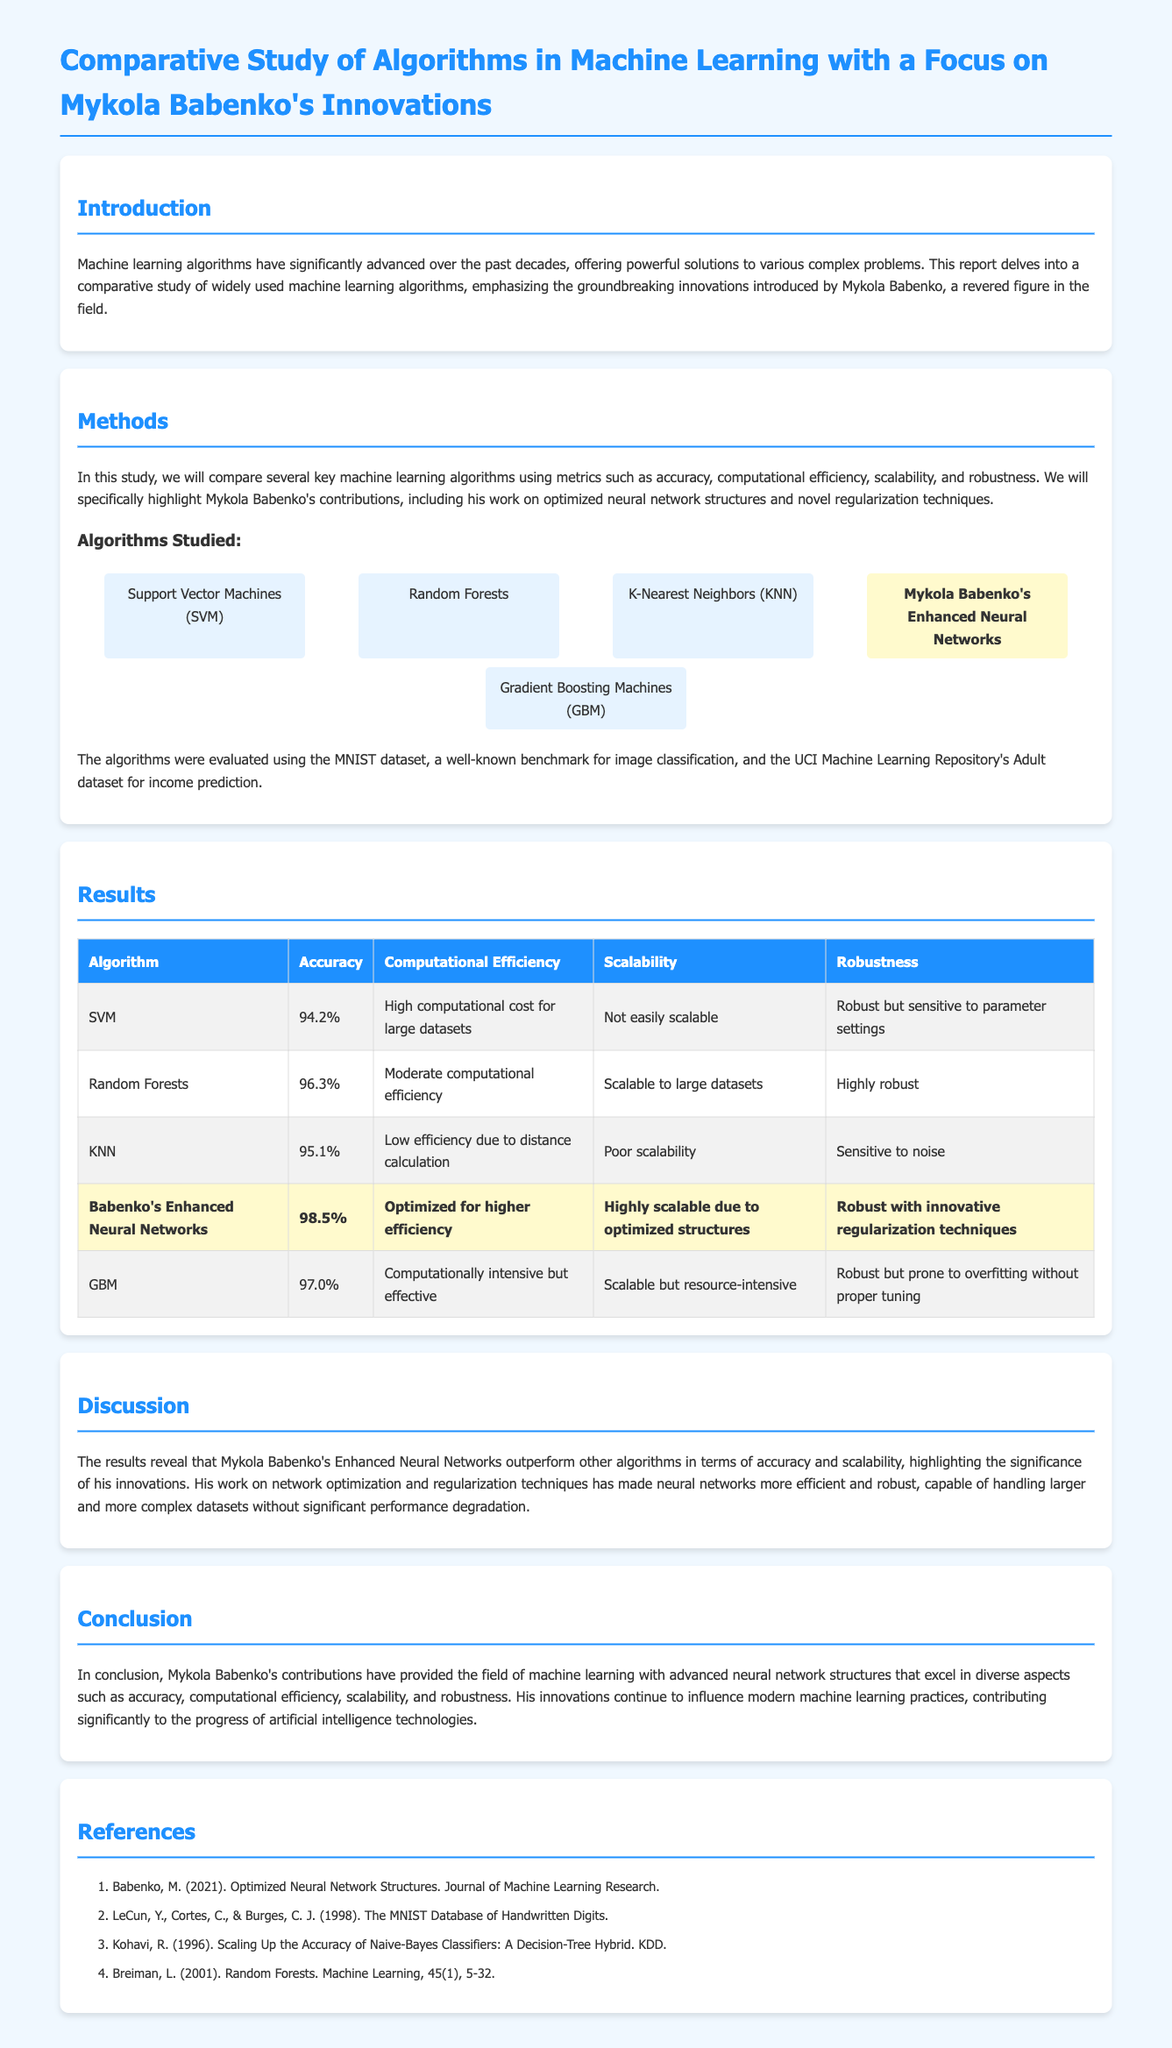What is the focus of this lab report? The lab report emphasizes the groundbreaking innovations introduced by Mykola Babenko in the field of machine learning.
Answer: Mykola Babenko's Innovations What datasets were used in the study? The document mentions the MNIST dataset and the UCI Machine Learning Repository's Adult dataset for evaluation.
Answer: MNIST and Adult dataset What is the accuracy of Mykola Babenko's Enhanced Neural Networks? The results table shows that the accuracy for Babenko's Enhanced Neural Networks is 98.5%.
Answer: 98.5% Which algorithm had the highest computational efficiency? The table indicates that Mykola Babenko's Enhanced Neural Networks was optimized for higher efficiency.
Answer: Enhanced Neural Networks What are two contributions of Mykola Babenko highlighted in the report? The report highlights optimized neural network structures and novel regularization techniques as contributions.
Answer: Optimized structures and regularization techniques What is the main conclusion drawn in the discussion section? The conclusion states that Mykola Babenko's contributions significantly advanced neural network capabilities in various aspects.
Answer: Advanced neural network capabilities Which two algorithms are noted for their robustness in the report? The report indicates that Random Forests and Babenko's Enhanced Neural Networks are highly robust.
Answer: Random Forests and Enhanced Neural Networks What color is used for the headings in the document? The headings are styled with a color code indicating a shade of blue, specifically #1e90ff.
Answer: Blue (#1e90ff) 